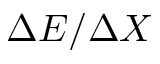<formula> <loc_0><loc_0><loc_500><loc_500>\Delta E / \Delta X</formula> 